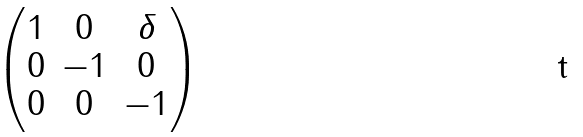Convert formula to latex. <formula><loc_0><loc_0><loc_500><loc_500>\begin{pmatrix} 1 & 0 & \delta \\ 0 & - 1 & 0 \\ 0 & 0 & - 1 \end{pmatrix}</formula> 